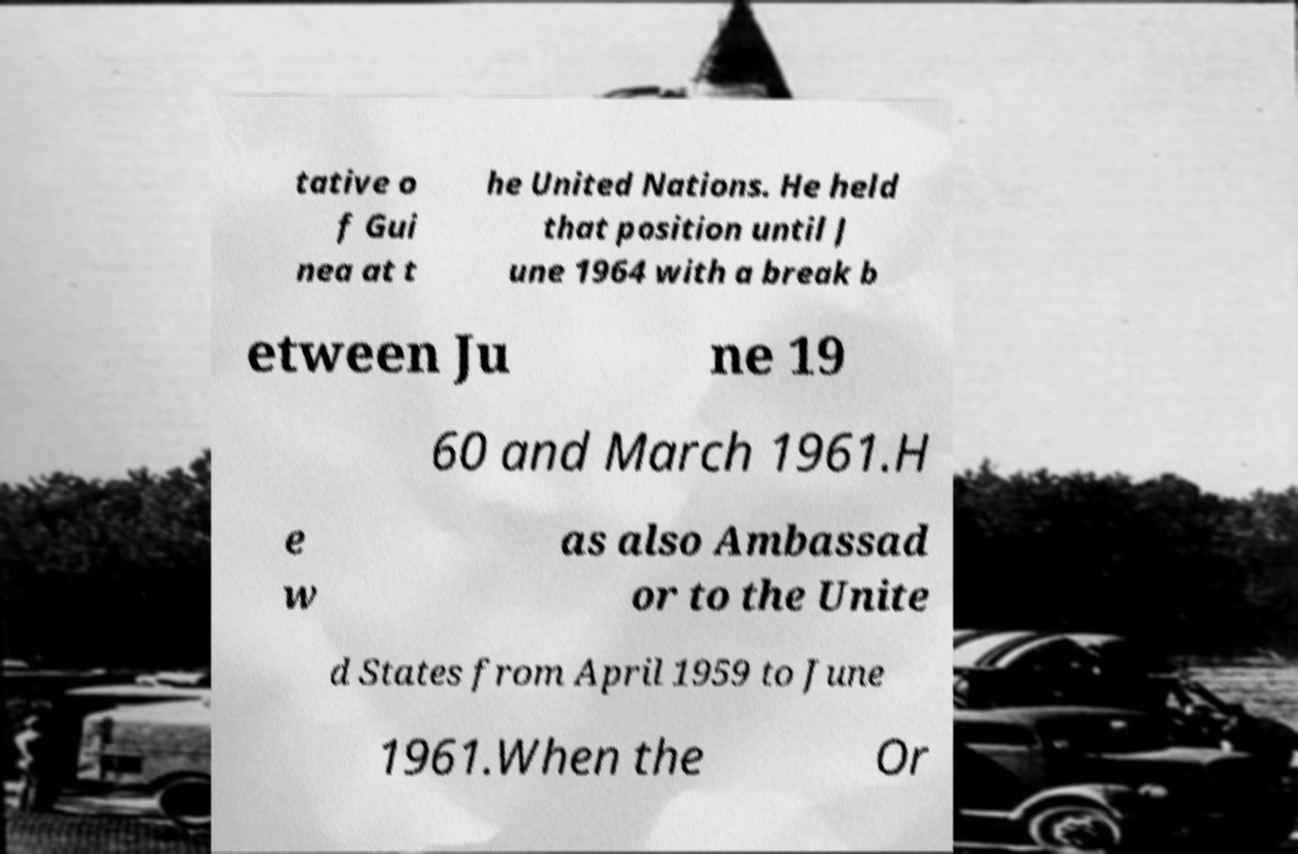For documentation purposes, I need the text within this image transcribed. Could you provide that? tative o f Gui nea at t he United Nations. He held that position until J une 1964 with a break b etween Ju ne 19 60 and March 1961.H e w as also Ambassad or to the Unite d States from April 1959 to June 1961.When the Or 